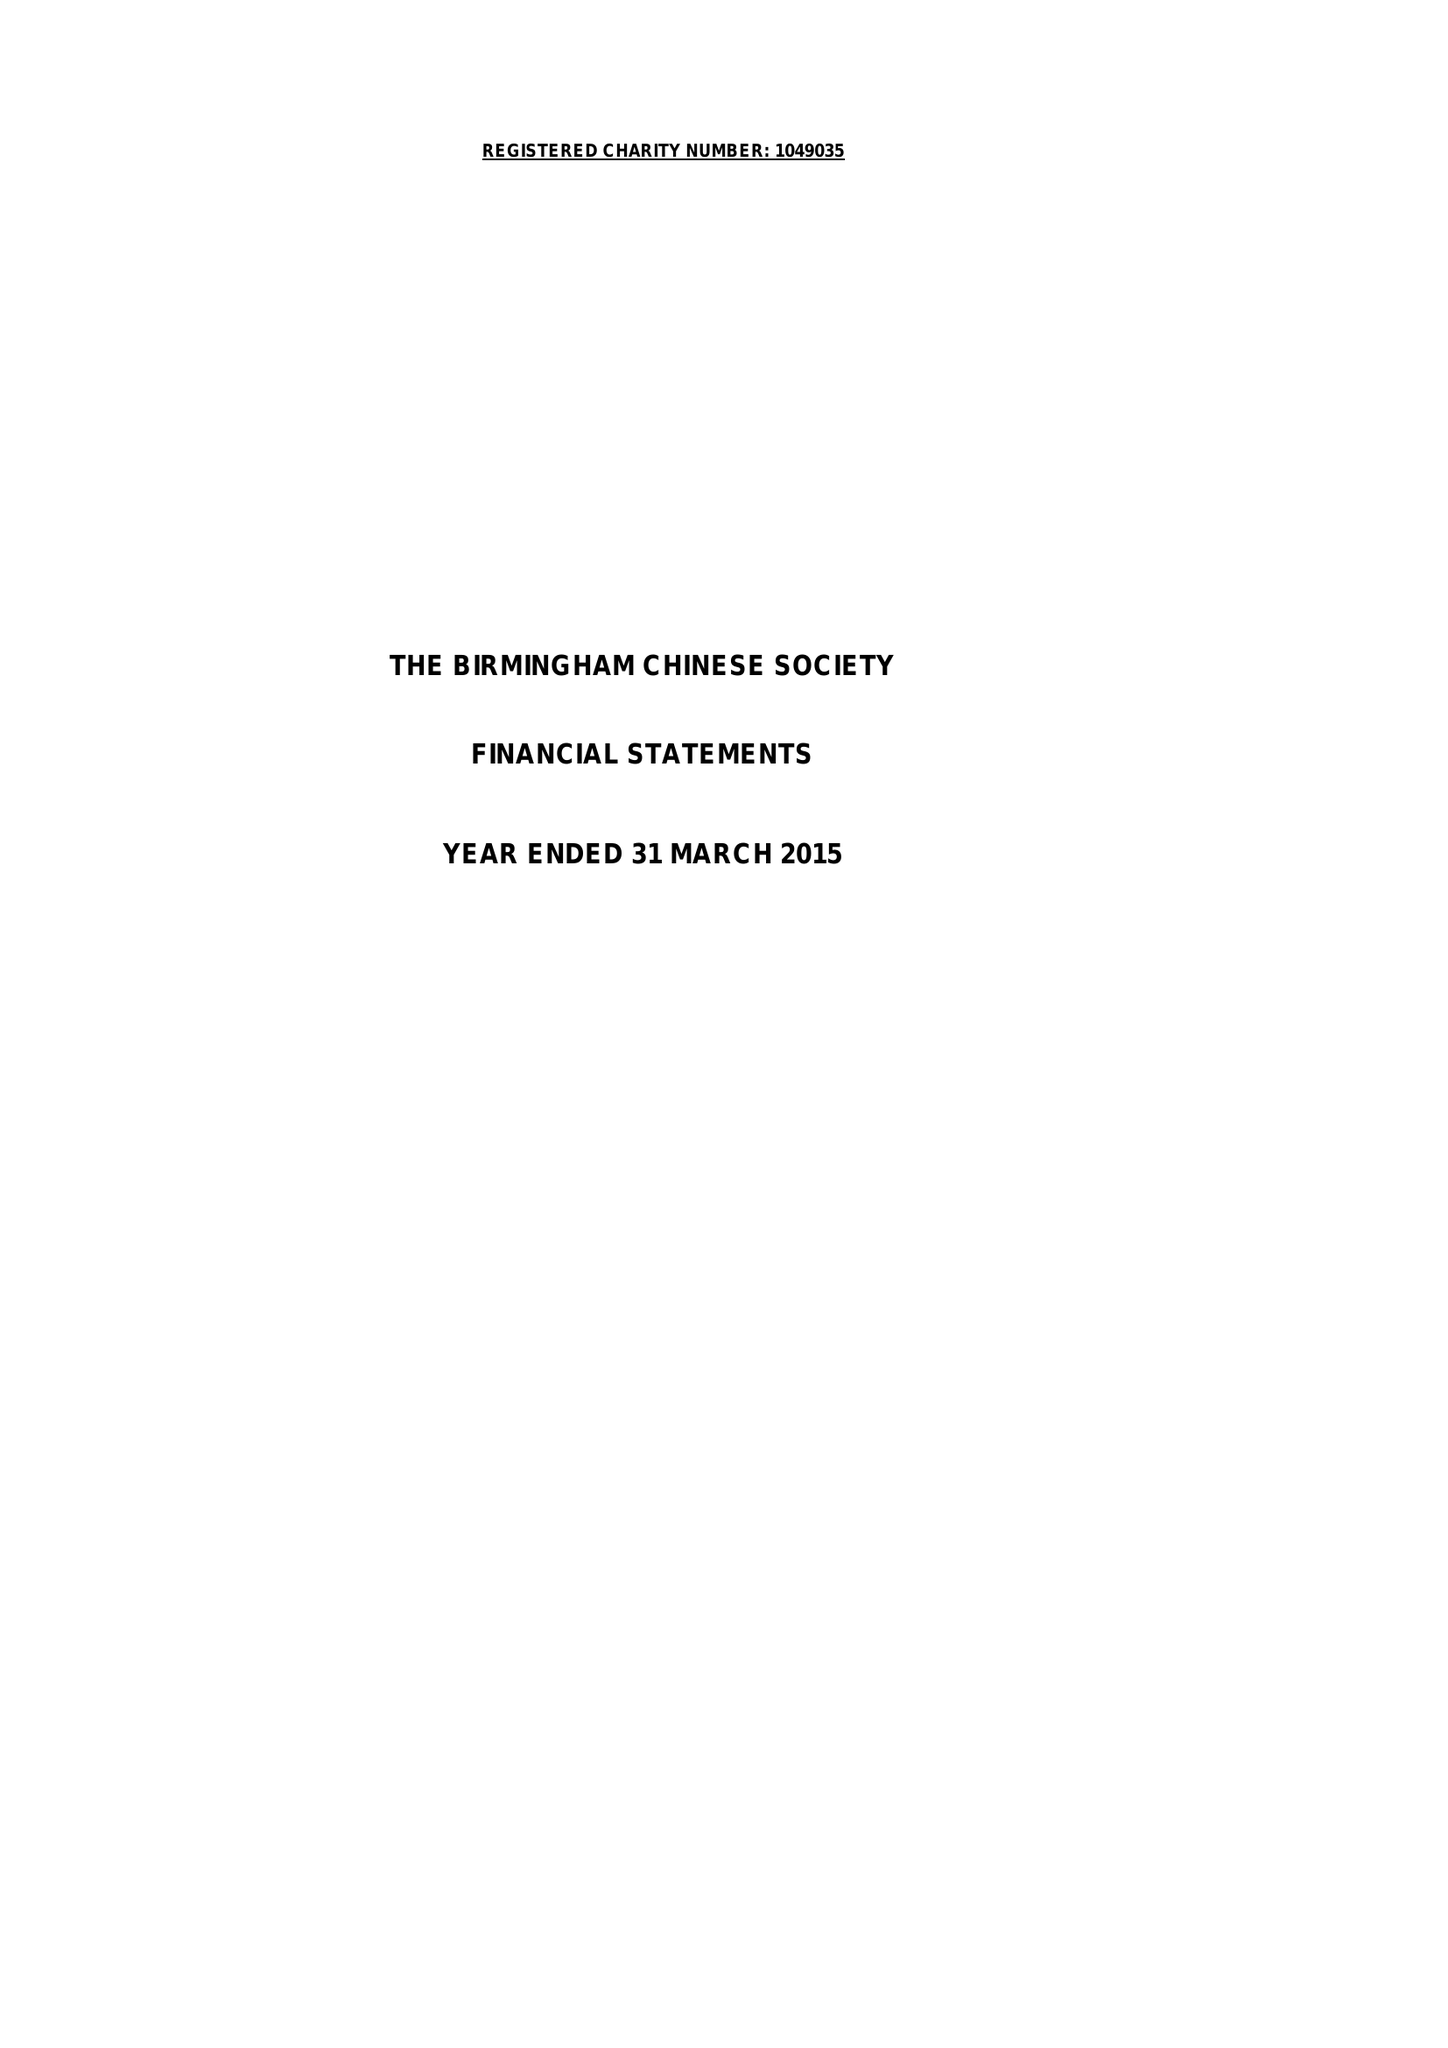What is the value for the spending_annually_in_british_pounds?
Answer the question using a single word or phrase. 58199.00 